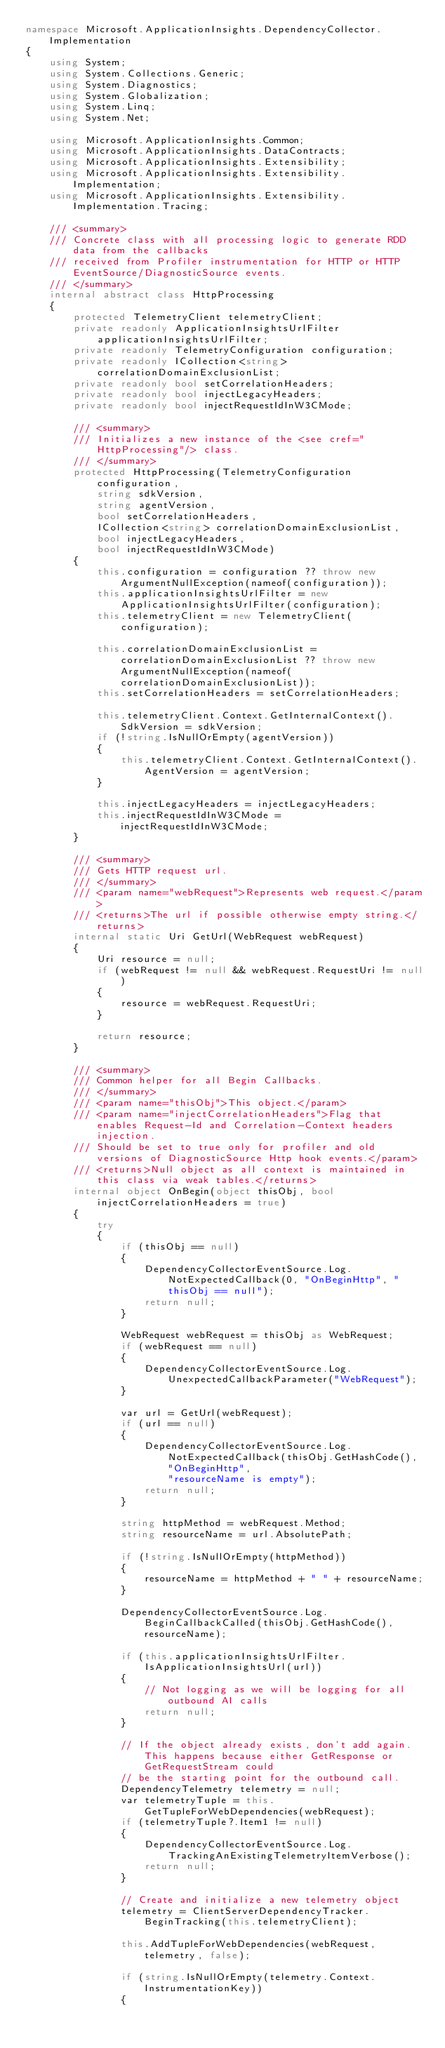Convert code to text. <code><loc_0><loc_0><loc_500><loc_500><_C#_>namespace Microsoft.ApplicationInsights.DependencyCollector.Implementation
{
    using System;
    using System.Collections.Generic;
    using System.Diagnostics;
    using System.Globalization;
    using System.Linq;
    using System.Net;

    using Microsoft.ApplicationInsights.Common;
    using Microsoft.ApplicationInsights.DataContracts;
    using Microsoft.ApplicationInsights.Extensibility;
    using Microsoft.ApplicationInsights.Extensibility.Implementation;
    using Microsoft.ApplicationInsights.Extensibility.Implementation.Tracing;

    /// <summary>
    /// Concrete class with all processing logic to generate RDD data from the callbacks
    /// received from Profiler instrumentation for HTTP or HTTP EventSource/DiagnosticSource events.   
    /// </summary>
    internal abstract class HttpProcessing
    {
        protected TelemetryClient telemetryClient;
        private readonly ApplicationInsightsUrlFilter applicationInsightsUrlFilter;
        private readonly TelemetryConfiguration configuration;
        private readonly ICollection<string> correlationDomainExclusionList;
        private readonly bool setCorrelationHeaders;
        private readonly bool injectLegacyHeaders;
        private readonly bool injectRequestIdInW3CMode;

        /// <summary>
        /// Initializes a new instance of the <see cref="HttpProcessing"/> class.
        /// </summary>
        protected HttpProcessing(TelemetryConfiguration configuration,
            string sdkVersion, 
            string agentVersion, 
            bool setCorrelationHeaders, 
            ICollection<string> correlationDomainExclusionList, 
            bool injectLegacyHeaders,
            bool injectRequestIdInW3CMode)
        {
            this.configuration = configuration ?? throw new ArgumentNullException(nameof(configuration));
            this.applicationInsightsUrlFilter = new ApplicationInsightsUrlFilter(configuration);
            this.telemetryClient = new TelemetryClient(configuration);

            this.correlationDomainExclusionList = correlationDomainExclusionList ?? throw new ArgumentNullException(nameof(correlationDomainExclusionList));
            this.setCorrelationHeaders = setCorrelationHeaders;

            this.telemetryClient.Context.GetInternalContext().SdkVersion = sdkVersion;
            if (!string.IsNullOrEmpty(agentVersion))
            {
                this.telemetryClient.Context.GetInternalContext().AgentVersion = agentVersion;
            }

            this.injectLegacyHeaders = injectLegacyHeaders;
            this.injectRequestIdInW3CMode = injectRequestIdInW3CMode;
        }

        /// <summary>
        /// Gets HTTP request url.
        /// </summary>
        /// <param name="webRequest">Represents web request.</param>
        /// <returns>The url if possible otherwise empty string.</returns>
        internal static Uri GetUrl(WebRequest webRequest)
        {
            Uri resource = null;
            if (webRequest != null && webRequest.RequestUri != null)
            {
                resource = webRequest.RequestUri;
            }

            return resource;
        }
        
        /// <summary>
        /// Common helper for all Begin Callbacks.
        /// </summary>
        /// <param name="thisObj">This object.</param>
        /// <param name="injectCorrelationHeaders">Flag that enables Request-Id and Correlation-Context headers injection.
        /// Should be set to true only for profiler and old versions of DiagnosticSource Http hook events.</param>
        /// <returns>Null object as all context is maintained in this class via weak tables.</returns>
        internal object OnBegin(object thisObj, bool injectCorrelationHeaders = true)
        {
            try
            {
                if (thisObj == null)
                {
                    DependencyCollectorEventSource.Log.NotExpectedCallback(0, "OnBeginHttp", "thisObj == null");
                    return null;
                }

                WebRequest webRequest = thisObj as WebRequest;
                if (webRequest == null)
                {
                    DependencyCollectorEventSource.Log.UnexpectedCallbackParameter("WebRequest");
                }

                var url = GetUrl(webRequest);
                if (url == null)
                {
                    DependencyCollectorEventSource.Log.NotExpectedCallback(thisObj.GetHashCode(), "OnBeginHttp",
                        "resourceName is empty");
                    return null;
                }

                string httpMethod = webRequest.Method;
                string resourceName = url.AbsolutePath;

                if (!string.IsNullOrEmpty(httpMethod))
                {
                    resourceName = httpMethod + " " + resourceName;
                }

                DependencyCollectorEventSource.Log.BeginCallbackCalled(thisObj.GetHashCode(), resourceName);

                if (this.applicationInsightsUrlFilter.IsApplicationInsightsUrl(url))
                {
                    // Not logging as we will be logging for all outbound AI calls
                    return null;
                }

                // If the object already exists, don't add again. This happens because either GetResponse or GetRequestStream could
                // be the starting point for the outbound call.
                DependencyTelemetry telemetry = null;
                var telemetryTuple = this.GetTupleForWebDependencies(webRequest);
                if (telemetryTuple?.Item1 != null)
                {
                    DependencyCollectorEventSource.Log.TrackingAnExistingTelemetryItemVerbose();
                    return null;
                }

                // Create and initialize a new telemetry object
                telemetry = ClientServerDependencyTracker.BeginTracking(this.telemetryClient);

                this.AddTupleForWebDependencies(webRequest, telemetry, false);

                if (string.IsNullOrEmpty(telemetry.Context.InstrumentationKey))
                {</code> 